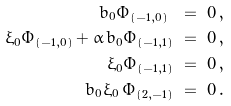<formula> <loc_0><loc_0><loc_500><loc_500>b _ { 0 } \Phi _ { ( - 1 , 0 ) } \ & = \ 0 \, , \\ \xi _ { 0 } \Phi _ { ( - 1 , 0 ) } + \alpha \, b _ { 0 } \Phi _ { ( - 1 , 1 ) } \ & = \ 0 \, , \\ \xi _ { 0 } \Phi _ { ( - 1 , 1 ) } \ & = \ 0 \, , \\ b _ { 0 } \xi _ { 0 } \, \Phi _ { ( 2 , - 1 ) } \ & = \ 0 \, . \\</formula> 